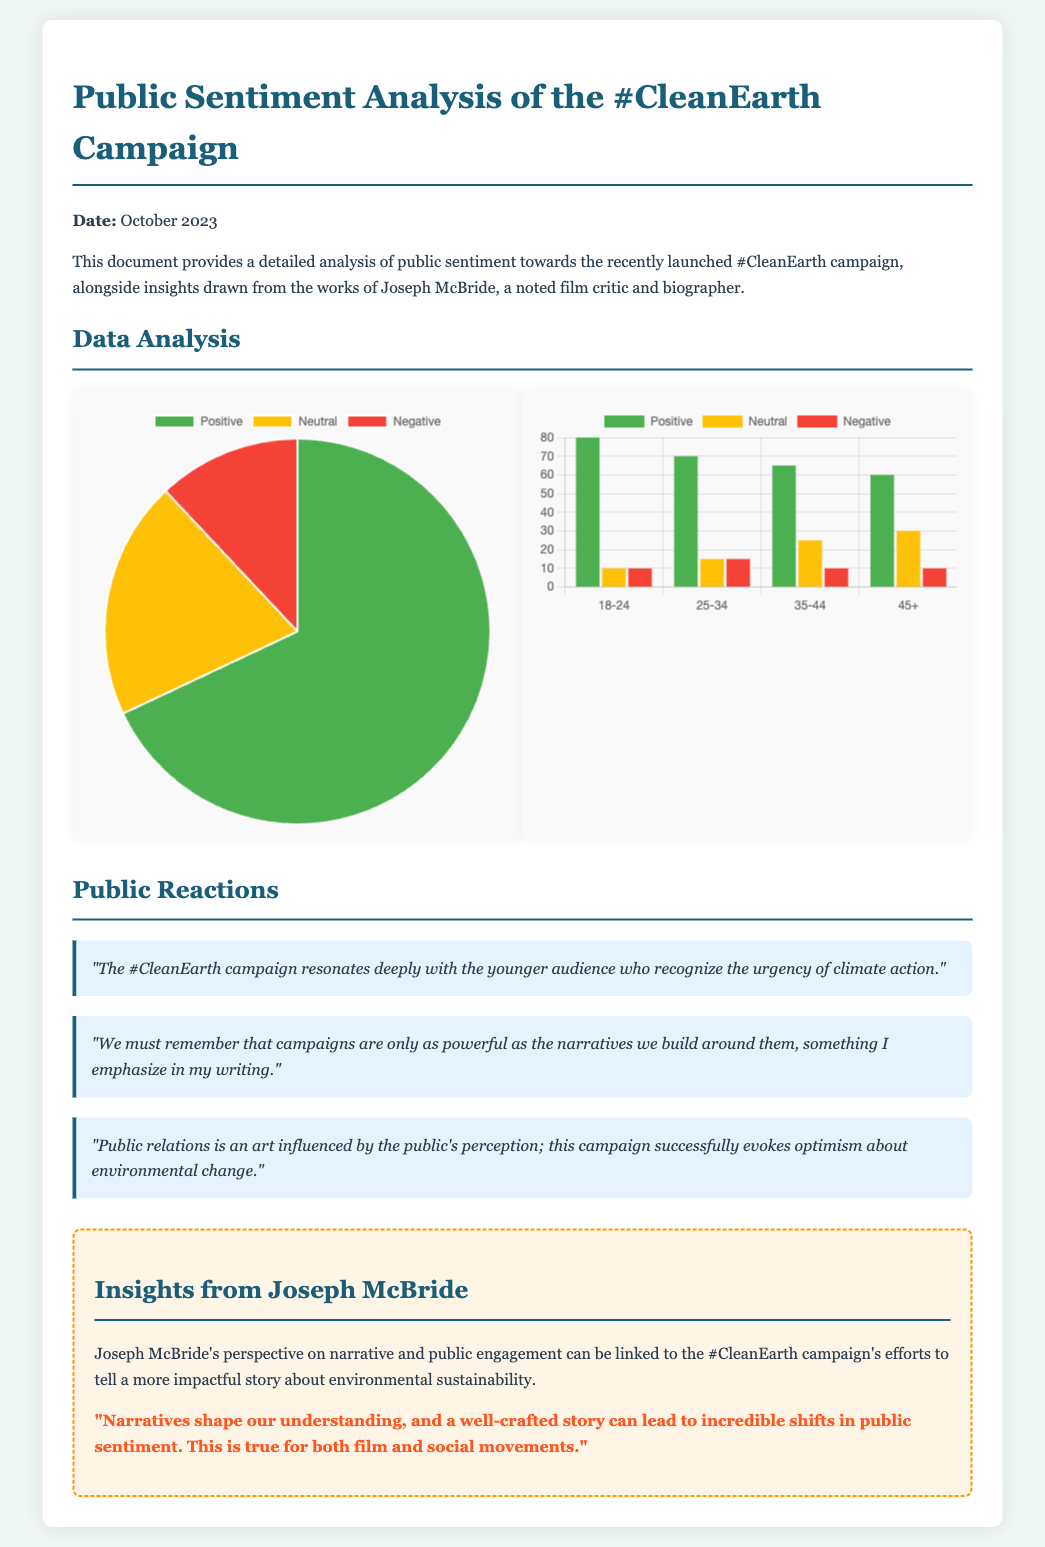What is the title of the document? The title can be found at the top of the document, which provides the main subject of the analysis.
Answer: Public Sentiment Analysis of the #CleanEarth Campaign What percentage of respondents expressed positive sentiment? The document presents a pie chart displaying the overall sentiment distribution, indicating the percentage of different sentiments.
Answer: 68 Which age group showed the highest positive sentiment? The bar chart illustrates the sentiment breakdown by age group, allowing us to identify which age category had the highest positive reaction.
Answer: 18-24 What type of chart is used to represent overall sentiment distribution? The document specifies the type of visualization employed for depicting the sentiment distribution among respondents.
Answer: Pie What insight does Joseph McBride provide regarding narratives? The insights section quotes Joseph McBride, emphasizing an important characteristic of narratives in shaping public sentiment.
Answer: "Narratives shape our understanding, and a well-crafted story can lead to incredible shifts in public sentiment. This is true for both film and social movements." Which color represents negative sentiment in the pie chart? The legend accompanying the pie chart indicates the color codes used to represent different sentiments.
Answer: Red What is the overall sentiment ratio of neutral responses? By assessing the pie chart data, the total amount of neutral responses can be calculated to find its proportion.
Answer: 20 How many age groups are displayed in the demographics chart? The demographics chart consists of multiple categories representing different age groups and their sentiment levels.
Answer: Four What is the date of the analysis? The initial section of the document states the date to indicate when the sentiment analysis was conducted.
Answer: October 2023 